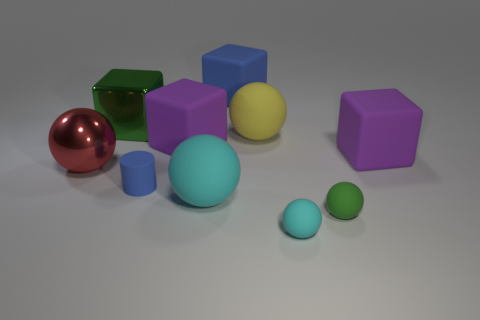Are there more large green matte cylinders than large metal balls?
Offer a terse response. No. There is a object that is to the left of the large green metallic cube; what is its color?
Your answer should be very brief. Red. What is the size of the matte object that is behind the large red object and on the left side of the big cyan rubber ball?
Make the answer very short. Large. How many green balls are the same size as the blue matte cylinder?
Your answer should be very brief. 1. What is the material of the large cyan object that is the same shape as the green matte object?
Ensure brevity in your answer.  Rubber. Is the shape of the small green thing the same as the big blue rubber thing?
Ensure brevity in your answer.  No. There is a small cyan object; what number of large yellow things are to the right of it?
Offer a very short reply. 0. There is a blue thing that is behind the blue cylinder that is to the right of the large metal ball; what shape is it?
Ensure brevity in your answer.  Cube. What shape is the large red thing that is made of the same material as the large green thing?
Keep it short and to the point. Sphere. There is a cyan object right of the big cyan rubber thing; is it the same size as the green object right of the large blue block?
Make the answer very short. Yes. 